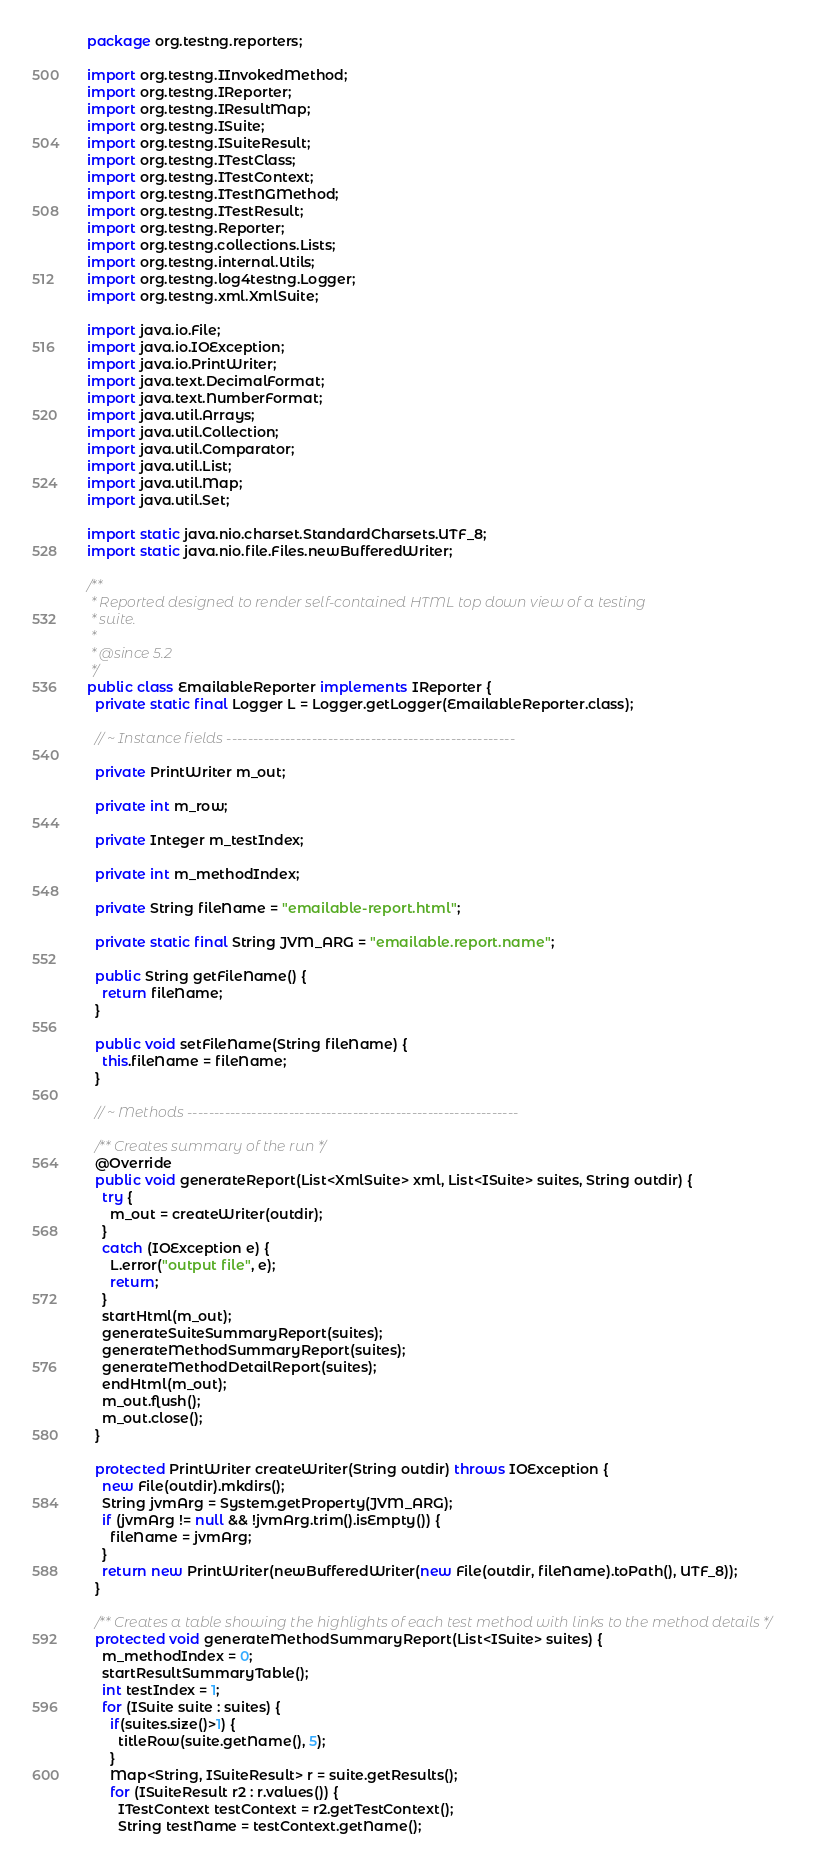Convert code to text. <code><loc_0><loc_0><loc_500><loc_500><_Java_>package org.testng.reporters;

import org.testng.IInvokedMethod;
import org.testng.IReporter;
import org.testng.IResultMap;
import org.testng.ISuite;
import org.testng.ISuiteResult;
import org.testng.ITestClass;
import org.testng.ITestContext;
import org.testng.ITestNGMethod;
import org.testng.ITestResult;
import org.testng.Reporter;
import org.testng.collections.Lists;
import org.testng.internal.Utils;
import org.testng.log4testng.Logger;
import org.testng.xml.XmlSuite;

import java.io.File;
import java.io.IOException;
import java.io.PrintWriter;
import java.text.DecimalFormat;
import java.text.NumberFormat;
import java.util.Arrays;
import java.util.Collection;
import java.util.Comparator;
import java.util.List;
import java.util.Map;
import java.util.Set;

import static java.nio.charset.StandardCharsets.UTF_8;
import static java.nio.file.Files.newBufferedWriter;

/**
 * Reported designed to render self-contained HTML top down view of a testing
 * suite.
 *
 * @since 5.2
 */
public class EmailableReporter implements IReporter {
  private static final Logger L = Logger.getLogger(EmailableReporter.class);

  // ~ Instance fields ------------------------------------------------------

  private PrintWriter m_out;

  private int m_row;

  private Integer m_testIndex;

  private int m_methodIndex;

  private String fileName = "emailable-report.html";

  private static final String JVM_ARG = "emailable.report.name";

  public String getFileName() {
    return fileName;
  }

  public void setFileName(String fileName) {
    this.fileName = fileName;
  }

  // ~ Methods --------------------------------------------------------------

  /** Creates summary of the run */
  @Override
  public void generateReport(List<XmlSuite> xml, List<ISuite> suites, String outdir) {
    try {
      m_out = createWriter(outdir);
    }
    catch (IOException e) {
      L.error("output file", e);
      return;
    }
    startHtml(m_out);
    generateSuiteSummaryReport(suites);
    generateMethodSummaryReport(suites);
    generateMethodDetailReport(suites);
    endHtml(m_out);
    m_out.flush();
    m_out.close();
  }

  protected PrintWriter createWriter(String outdir) throws IOException {
    new File(outdir).mkdirs();
    String jvmArg = System.getProperty(JVM_ARG);
    if (jvmArg != null && !jvmArg.trim().isEmpty()) {
      fileName = jvmArg;
    }
    return new PrintWriter(newBufferedWriter(new File(outdir, fileName).toPath(), UTF_8));
  }

  /** Creates a table showing the highlights of each test method with links to the method details */
  protected void generateMethodSummaryReport(List<ISuite> suites) {
    m_methodIndex = 0;
    startResultSummaryTable();
    int testIndex = 1;
    for (ISuite suite : suites) {
      if(suites.size()>1) {
        titleRow(suite.getName(), 5);
      }
      Map<String, ISuiteResult> r = suite.getResults();
      for (ISuiteResult r2 : r.values()) {
        ITestContext testContext = r2.getTestContext();
        String testName = testContext.getName();</code> 